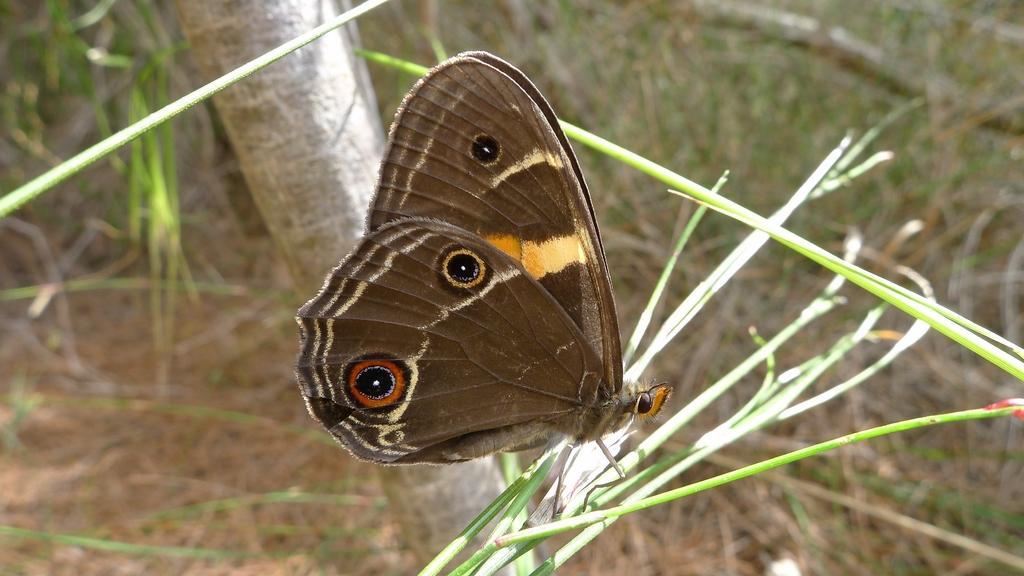Can you describe this image briefly? In this image I can see a butterfly, which is brown in color. This looks like a grass. In the background, I think this is the tree trunk. 